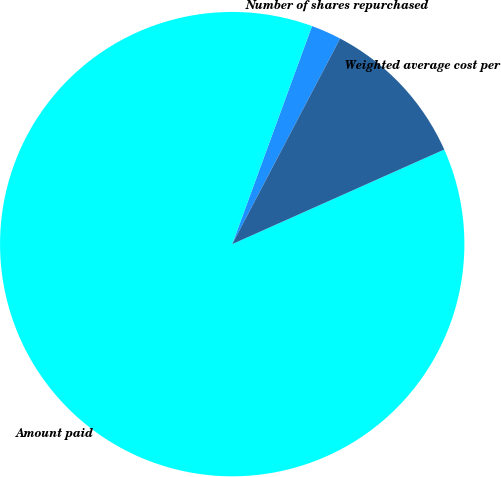Convert chart. <chart><loc_0><loc_0><loc_500><loc_500><pie_chart><fcel>Number of shares repurchased<fcel>Amount paid<fcel>Weighted average cost per<nl><fcel>2.11%<fcel>87.26%<fcel>10.63%<nl></chart> 